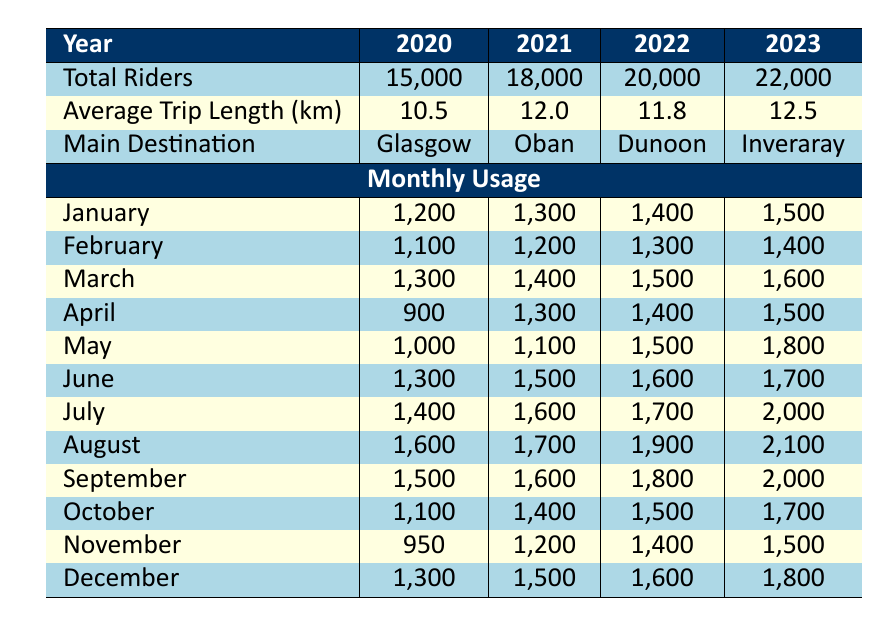What was the main destination for community transportation in 2022? According to the table, the main destination listed for the year 2022 is "Dunoon."
Answer: Dunoon How many total riders used community transportation in 2021? The table states that the total riders for the year 2021 is 18,000.
Answer: 18,000 What was the increase in total riders from 2020 to 2023? The total riders increased by subtracting the 2020 figure (15,000) from the 2023 figure (22,000), resulting in an increase of 7,000.
Answer: 7,000 Did the average trip length in 2022 exceed 11 kilometers? The table shows that the average trip length for 2022 is 11.8 kilometers, which is greater than 11 kilometers.
Answer: Yes Which month had the highest number of riders in 2023? In 2023, the monthly usage shows that August had the highest number of riders, with a total of 2,100.
Answer: August What is the average number of riders in July over the four years? To find the average, we add the total riders in July from each year: 1,400 (2020) + 1,600 (2021) + 1,700 (2022) + 2,000 (2023) = 6,700. Dividing by 4, we get an average of 1,675 riders.
Answer: 1,675 Was the number of riders in May consistently increasing from 2020 to 2023? Reviewing the May figures: 1,000 (2020), 1,100 (2021), 1,500 (2022), and 1,800 (2023). Since these numbers show a consistent increase, the answer is yes.
Answer: Yes What was the average number of riders during the month of October over the four years? The riders for October are: 1,100 (2020), 1,400 (2021), 1,500 (2022), and 1,700 (2023). Summing these gives 5,700, and dividing by 4 gives an average of 1,425.
Answer: 1,425 Which year had the lowest average trip length? The average trip lengths for the years indicate that 2020 had the lowest at 10.5 kilometers, compared to the other years.
Answer: 2020 